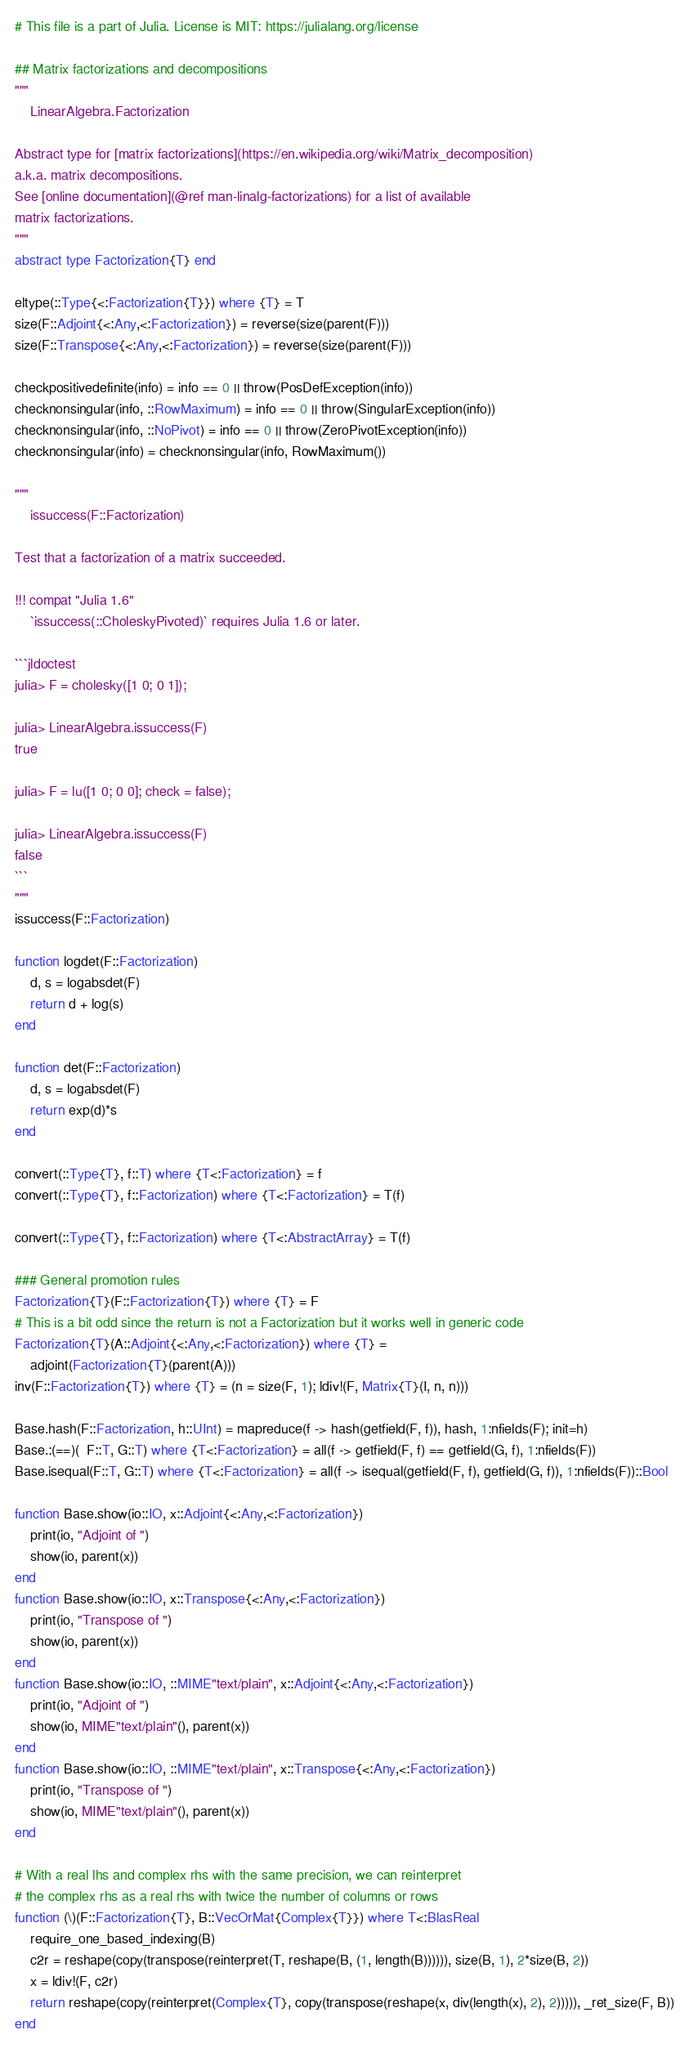Convert code to text. <code><loc_0><loc_0><loc_500><loc_500><_Julia_># This file is a part of Julia. License is MIT: https://julialang.org/license

## Matrix factorizations and decompositions
"""
    LinearAlgebra.Factorization

Abstract type for [matrix factorizations](https://en.wikipedia.org/wiki/Matrix_decomposition)
a.k.a. matrix decompositions.
See [online documentation](@ref man-linalg-factorizations) for a list of available
matrix factorizations.
"""
abstract type Factorization{T} end

eltype(::Type{<:Factorization{T}}) where {T} = T
size(F::Adjoint{<:Any,<:Factorization}) = reverse(size(parent(F)))
size(F::Transpose{<:Any,<:Factorization}) = reverse(size(parent(F)))

checkpositivedefinite(info) = info == 0 || throw(PosDefException(info))
checknonsingular(info, ::RowMaximum) = info == 0 || throw(SingularException(info))
checknonsingular(info, ::NoPivot) = info == 0 || throw(ZeroPivotException(info))
checknonsingular(info) = checknonsingular(info, RowMaximum())

"""
    issuccess(F::Factorization)

Test that a factorization of a matrix succeeded.

!!! compat "Julia 1.6"
    `issuccess(::CholeskyPivoted)` requires Julia 1.6 or later.

```jldoctest
julia> F = cholesky([1 0; 0 1]);

julia> LinearAlgebra.issuccess(F)
true

julia> F = lu([1 0; 0 0]; check = false);

julia> LinearAlgebra.issuccess(F)
false
```
"""
issuccess(F::Factorization)

function logdet(F::Factorization)
    d, s = logabsdet(F)
    return d + log(s)
end

function det(F::Factorization)
    d, s = logabsdet(F)
    return exp(d)*s
end

convert(::Type{T}, f::T) where {T<:Factorization} = f
convert(::Type{T}, f::Factorization) where {T<:Factorization} = T(f)

convert(::Type{T}, f::Factorization) where {T<:AbstractArray} = T(f)

### General promotion rules
Factorization{T}(F::Factorization{T}) where {T} = F
# This is a bit odd since the return is not a Factorization but it works well in generic code
Factorization{T}(A::Adjoint{<:Any,<:Factorization}) where {T} =
    adjoint(Factorization{T}(parent(A)))
inv(F::Factorization{T}) where {T} = (n = size(F, 1); ldiv!(F, Matrix{T}(I, n, n)))

Base.hash(F::Factorization, h::UInt) = mapreduce(f -> hash(getfield(F, f)), hash, 1:nfields(F); init=h)
Base.:(==)(  F::T, G::T) where {T<:Factorization} = all(f -> getfield(F, f) == getfield(G, f), 1:nfields(F))
Base.isequal(F::T, G::T) where {T<:Factorization} = all(f -> isequal(getfield(F, f), getfield(G, f)), 1:nfields(F))::Bool

function Base.show(io::IO, x::Adjoint{<:Any,<:Factorization})
    print(io, "Adjoint of ")
    show(io, parent(x))
end
function Base.show(io::IO, x::Transpose{<:Any,<:Factorization})
    print(io, "Transpose of ")
    show(io, parent(x))
end
function Base.show(io::IO, ::MIME"text/plain", x::Adjoint{<:Any,<:Factorization})
    print(io, "Adjoint of ")
    show(io, MIME"text/plain"(), parent(x))
end
function Base.show(io::IO, ::MIME"text/plain", x::Transpose{<:Any,<:Factorization})
    print(io, "Transpose of ")
    show(io, MIME"text/plain"(), parent(x))
end

# With a real lhs and complex rhs with the same precision, we can reinterpret
# the complex rhs as a real rhs with twice the number of columns or rows
function (\)(F::Factorization{T}, B::VecOrMat{Complex{T}}) where T<:BlasReal
    require_one_based_indexing(B)
    c2r = reshape(copy(transpose(reinterpret(T, reshape(B, (1, length(B)))))), size(B, 1), 2*size(B, 2))
    x = ldiv!(F, c2r)
    return reshape(copy(reinterpret(Complex{T}, copy(transpose(reshape(x, div(length(x), 2), 2))))), _ret_size(F, B))
end</code> 